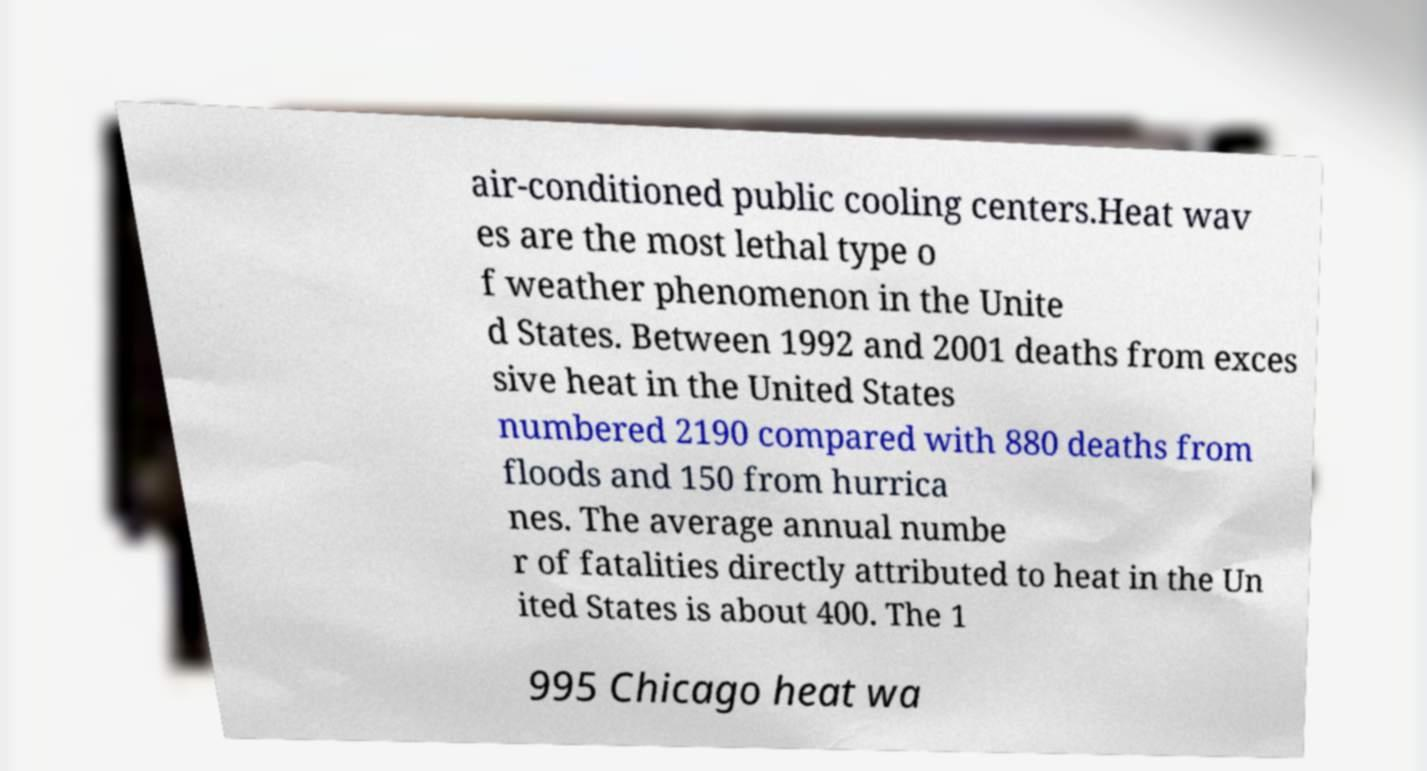Please identify and transcribe the text found in this image. air-conditioned public cooling centers.Heat wav es are the most lethal type o f weather phenomenon in the Unite d States. Between 1992 and 2001 deaths from exces sive heat in the United States numbered 2190 compared with 880 deaths from floods and 150 from hurrica nes. The average annual numbe r of fatalities directly attributed to heat in the Un ited States is about 400. The 1 995 Chicago heat wa 